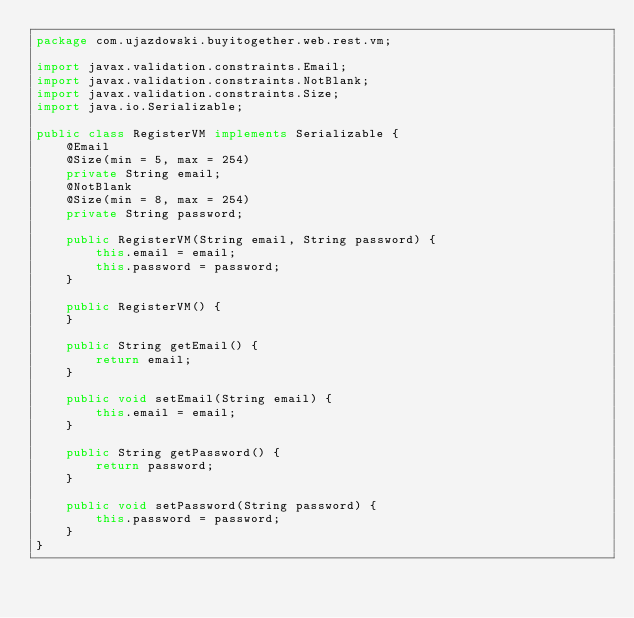Convert code to text. <code><loc_0><loc_0><loc_500><loc_500><_Java_>package com.ujazdowski.buyitogether.web.rest.vm;

import javax.validation.constraints.Email;
import javax.validation.constraints.NotBlank;
import javax.validation.constraints.Size;
import java.io.Serializable;

public class RegisterVM implements Serializable {
    @Email
    @Size(min = 5, max = 254)
    private String email;
    @NotBlank
    @Size(min = 8, max = 254)
    private String password;

    public RegisterVM(String email, String password) {
        this.email = email;
        this.password = password;
    }

    public RegisterVM() {
    }

    public String getEmail() {
        return email;
    }

    public void setEmail(String email) {
        this.email = email;
    }

    public String getPassword() {
        return password;
    }

    public void setPassword(String password) {
        this.password = password;
    }
}
</code> 